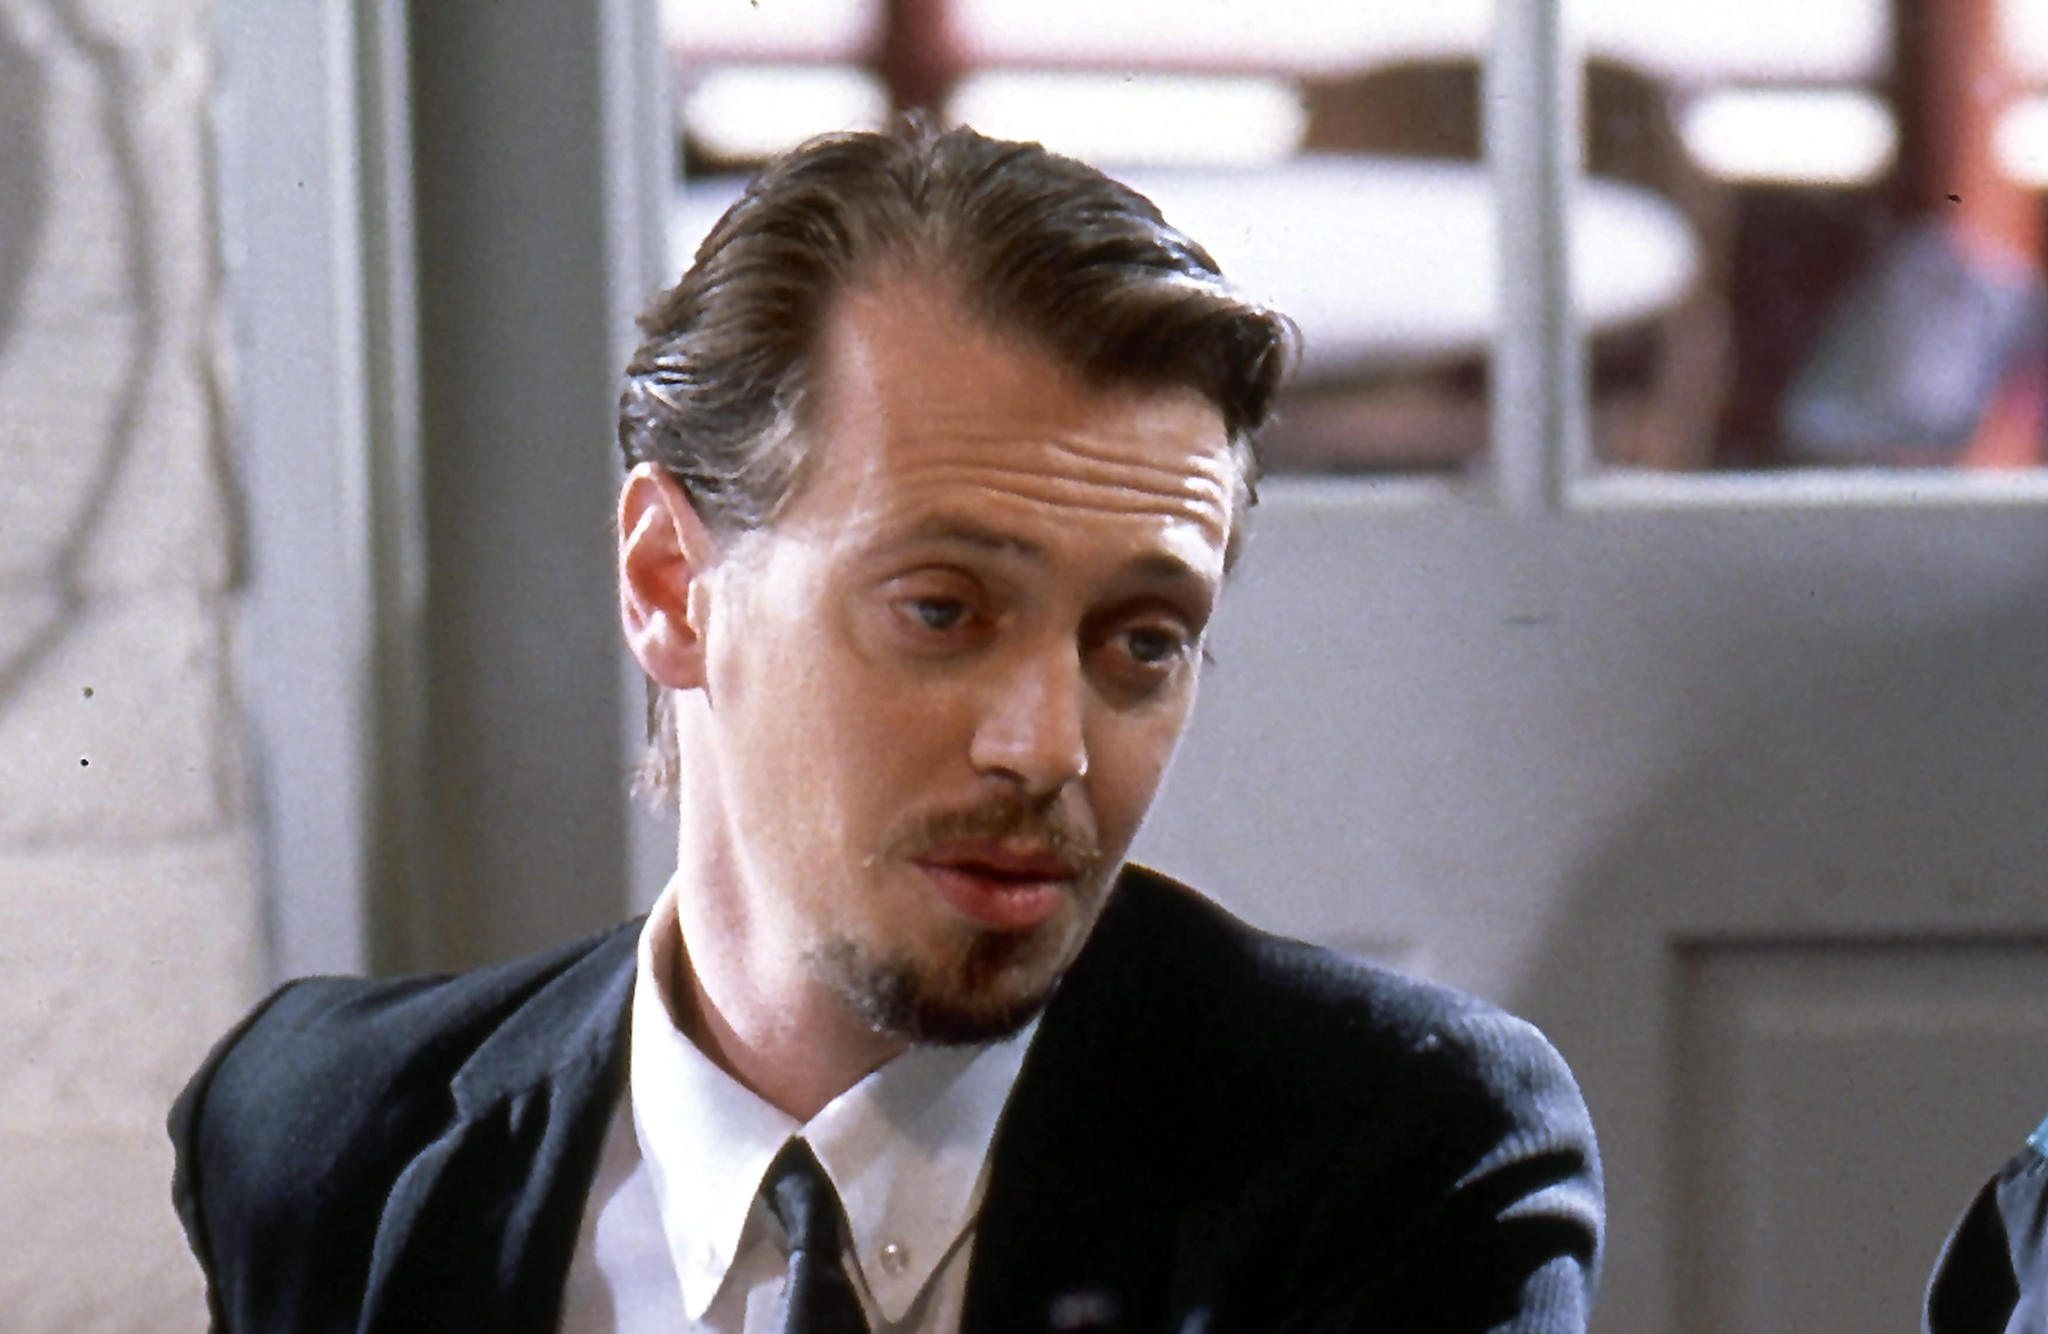Describe a possible backstory for this character that explains his intense, contemplative expression. Mr. Pink, once a small-time crook, clawed his way up through the criminal underworld with sheer determination and cunning. His intense, contemplative expression reveals the weight of his journey - from orphaned street ruffian to a feared and respected figure. Betrayed by those he trusted, he single-handedly survived double-crosses and shootouts, his mind finely attuned to the nuances of deceit and loyalty. This very moment in the café is reflective of his past; he’s contemplating the inevitability of another betrayal, perhaps planning his next move to safeguard his precarious position. The scars of his past are etched in his eyes, and the uncertainty of his future hangs heavy with every gaze beyond the frame. 